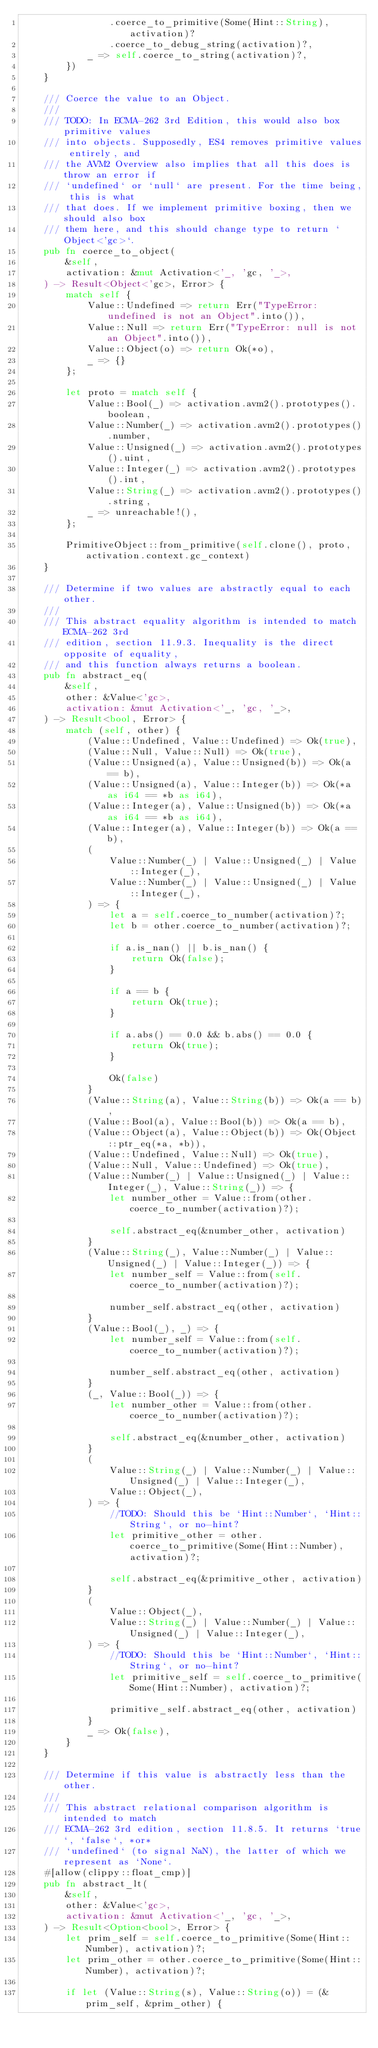Convert code to text. <code><loc_0><loc_0><loc_500><loc_500><_Rust_>                .coerce_to_primitive(Some(Hint::String), activation)?
                .coerce_to_debug_string(activation)?,
            _ => self.coerce_to_string(activation)?,
        })
    }

    /// Coerce the value to an Object.
    ///
    /// TODO: In ECMA-262 3rd Edition, this would also box primitive values
    /// into objects. Supposedly, ES4 removes primitive values entirely, and
    /// the AVM2 Overview also implies that all this does is throw an error if
    /// `undefined` or `null` are present. For the time being, this is what
    /// that does. If we implement primitive boxing, then we should also box
    /// them here, and this should change type to return `Object<'gc>`.
    pub fn coerce_to_object(
        &self,
        activation: &mut Activation<'_, 'gc, '_>,
    ) -> Result<Object<'gc>, Error> {
        match self {
            Value::Undefined => return Err("TypeError: undefined is not an Object".into()),
            Value::Null => return Err("TypeError: null is not an Object".into()),
            Value::Object(o) => return Ok(*o),
            _ => {}
        };

        let proto = match self {
            Value::Bool(_) => activation.avm2().prototypes().boolean,
            Value::Number(_) => activation.avm2().prototypes().number,
            Value::Unsigned(_) => activation.avm2().prototypes().uint,
            Value::Integer(_) => activation.avm2().prototypes().int,
            Value::String(_) => activation.avm2().prototypes().string,
            _ => unreachable!(),
        };

        PrimitiveObject::from_primitive(self.clone(), proto, activation.context.gc_context)
    }

    /// Determine if two values are abstractly equal to each other.
    ///
    /// This abstract equality algorithm is intended to match ECMA-262 3rd
    /// edition, section 11.9.3. Inequality is the direct opposite of equality,
    /// and this function always returns a boolean.
    pub fn abstract_eq(
        &self,
        other: &Value<'gc>,
        activation: &mut Activation<'_, 'gc, '_>,
    ) -> Result<bool, Error> {
        match (self, other) {
            (Value::Undefined, Value::Undefined) => Ok(true),
            (Value::Null, Value::Null) => Ok(true),
            (Value::Unsigned(a), Value::Unsigned(b)) => Ok(a == b),
            (Value::Unsigned(a), Value::Integer(b)) => Ok(*a as i64 == *b as i64),
            (Value::Integer(a), Value::Unsigned(b)) => Ok(*a as i64 == *b as i64),
            (Value::Integer(a), Value::Integer(b)) => Ok(a == b),
            (
                Value::Number(_) | Value::Unsigned(_) | Value::Integer(_),
                Value::Number(_) | Value::Unsigned(_) | Value::Integer(_),
            ) => {
                let a = self.coerce_to_number(activation)?;
                let b = other.coerce_to_number(activation)?;

                if a.is_nan() || b.is_nan() {
                    return Ok(false);
                }

                if a == b {
                    return Ok(true);
                }

                if a.abs() == 0.0 && b.abs() == 0.0 {
                    return Ok(true);
                }

                Ok(false)
            }
            (Value::String(a), Value::String(b)) => Ok(a == b),
            (Value::Bool(a), Value::Bool(b)) => Ok(a == b),
            (Value::Object(a), Value::Object(b)) => Ok(Object::ptr_eq(*a, *b)),
            (Value::Undefined, Value::Null) => Ok(true),
            (Value::Null, Value::Undefined) => Ok(true),
            (Value::Number(_) | Value::Unsigned(_) | Value::Integer(_), Value::String(_)) => {
                let number_other = Value::from(other.coerce_to_number(activation)?);

                self.abstract_eq(&number_other, activation)
            }
            (Value::String(_), Value::Number(_) | Value::Unsigned(_) | Value::Integer(_)) => {
                let number_self = Value::from(self.coerce_to_number(activation)?);

                number_self.abstract_eq(other, activation)
            }
            (Value::Bool(_), _) => {
                let number_self = Value::from(self.coerce_to_number(activation)?);

                number_self.abstract_eq(other, activation)
            }
            (_, Value::Bool(_)) => {
                let number_other = Value::from(other.coerce_to_number(activation)?);

                self.abstract_eq(&number_other, activation)
            }
            (
                Value::String(_) | Value::Number(_) | Value::Unsigned(_) | Value::Integer(_),
                Value::Object(_),
            ) => {
                //TODO: Should this be `Hint::Number`, `Hint::String`, or no-hint?
                let primitive_other = other.coerce_to_primitive(Some(Hint::Number), activation)?;

                self.abstract_eq(&primitive_other, activation)
            }
            (
                Value::Object(_),
                Value::String(_) | Value::Number(_) | Value::Unsigned(_) | Value::Integer(_),
            ) => {
                //TODO: Should this be `Hint::Number`, `Hint::String`, or no-hint?
                let primitive_self = self.coerce_to_primitive(Some(Hint::Number), activation)?;

                primitive_self.abstract_eq(other, activation)
            }
            _ => Ok(false),
        }
    }

    /// Determine if this value is abstractly less than the other.
    ///
    /// This abstract relational comparison algorithm is intended to match
    /// ECMA-262 3rd edition, section 11.8.5. It returns `true`, `false`, *or*
    /// `undefined` (to signal NaN), the latter of which we represent as `None`.
    #[allow(clippy::float_cmp)]
    pub fn abstract_lt(
        &self,
        other: &Value<'gc>,
        activation: &mut Activation<'_, 'gc, '_>,
    ) -> Result<Option<bool>, Error> {
        let prim_self = self.coerce_to_primitive(Some(Hint::Number), activation)?;
        let prim_other = other.coerce_to_primitive(Some(Hint::Number), activation)?;

        if let (Value::String(s), Value::String(o)) = (&prim_self, &prim_other) {</code> 